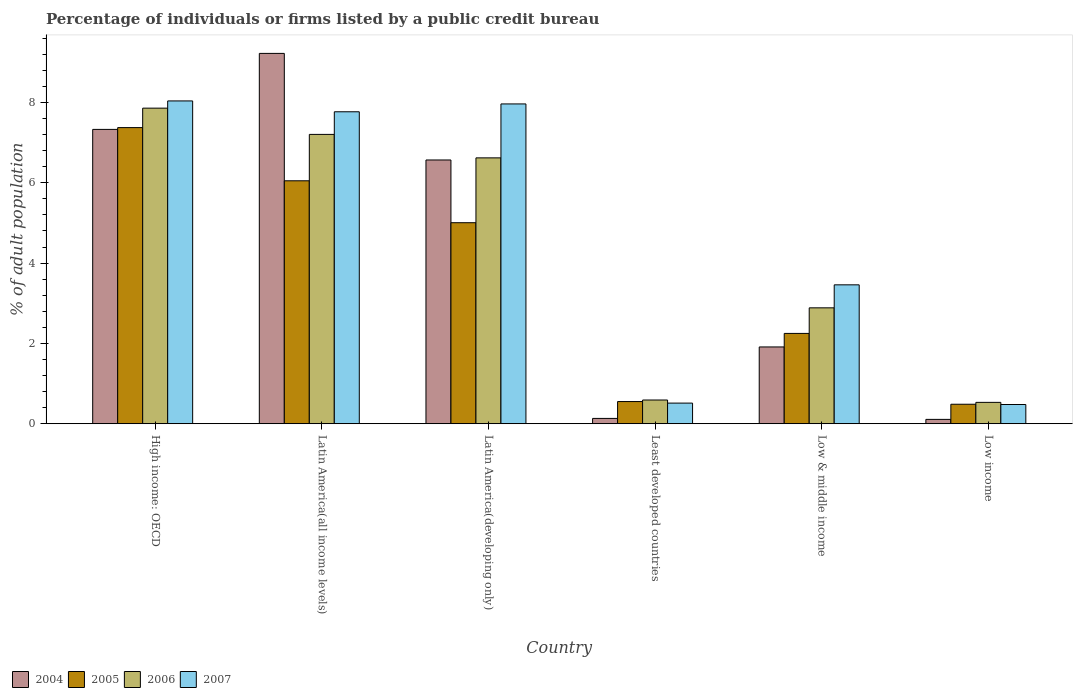How many different coloured bars are there?
Ensure brevity in your answer.  4. How many groups of bars are there?
Your answer should be very brief. 6. Are the number of bars per tick equal to the number of legend labels?
Offer a very short reply. Yes. How many bars are there on the 1st tick from the right?
Ensure brevity in your answer.  4. What is the label of the 5th group of bars from the left?
Keep it short and to the point. Low & middle income. In how many cases, is the number of bars for a given country not equal to the number of legend labels?
Ensure brevity in your answer.  0. What is the percentage of population listed by a public credit bureau in 2004 in Low & middle income?
Offer a terse response. 1.91. Across all countries, what is the maximum percentage of population listed by a public credit bureau in 2007?
Ensure brevity in your answer.  8.04. Across all countries, what is the minimum percentage of population listed by a public credit bureau in 2006?
Ensure brevity in your answer.  0.53. In which country was the percentage of population listed by a public credit bureau in 2006 maximum?
Provide a succinct answer. High income: OECD. In which country was the percentage of population listed by a public credit bureau in 2004 minimum?
Keep it short and to the point. Low income. What is the total percentage of population listed by a public credit bureau in 2007 in the graph?
Offer a terse response. 28.22. What is the difference between the percentage of population listed by a public credit bureau in 2006 in High income: OECD and that in Low income?
Your response must be concise. 7.32. What is the difference between the percentage of population listed by a public credit bureau in 2006 in Latin America(developing only) and the percentage of population listed by a public credit bureau in 2007 in Low & middle income?
Offer a terse response. 3.16. What is the average percentage of population listed by a public credit bureau in 2004 per country?
Provide a short and direct response. 4.21. What is the difference between the percentage of population listed by a public credit bureau of/in 2007 and percentage of population listed by a public credit bureau of/in 2006 in Low income?
Keep it short and to the point. -0.05. What is the ratio of the percentage of population listed by a public credit bureau in 2006 in High income: OECD to that in Latin America(developing only)?
Your answer should be compact. 1.19. What is the difference between the highest and the second highest percentage of population listed by a public credit bureau in 2005?
Ensure brevity in your answer.  -1.04. What is the difference between the highest and the lowest percentage of population listed by a public credit bureau in 2004?
Your answer should be compact. 9.11. Is the sum of the percentage of population listed by a public credit bureau in 2005 in Latin America(all income levels) and Least developed countries greater than the maximum percentage of population listed by a public credit bureau in 2007 across all countries?
Give a very brief answer. No. What does the 4th bar from the left in High income: OECD represents?
Provide a succinct answer. 2007. What does the 3rd bar from the right in High income: OECD represents?
Provide a short and direct response. 2005. Are all the bars in the graph horizontal?
Provide a succinct answer. No. Are the values on the major ticks of Y-axis written in scientific E-notation?
Offer a terse response. No. Does the graph contain any zero values?
Provide a succinct answer. No. Does the graph contain grids?
Your answer should be compact. No. Where does the legend appear in the graph?
Your answer should be compact. Bottom left. How many legend labels are there?
Provide a short and direct response. 4. How are the legend labels stacked?
Offer a very short reply. Horizontal. What is the title of the graph?
Ensure brevity in your answer.  Percentage of individuals or firms listed by a public credit bureau. What is the label or title of the X-axis?
Your answer should be compact. Country. What is the label or title of the Y-axis?
Your answer should be compact. % of adult population. What is the % of adult population of 2004 in High income: OECD?
Keep it short and to the point. 7.33. What is the % of adult population of 2005 in High income: OECD?
Offer a very short reply. 7.37. What is the % of adult population of 2006 in High income: OECD?
Provide a short and direct response. 7.86. What is the % of adult population of 2007 in High income: OECD?
Ensure brevity in your answer.  8.04. What is the % of adult population of 2004 in Latin America(all income levels)?
Your answer should be very brief. 9.22. What is the % of adult population in 2005 in Latin America(all income levels)?
Provide a short and direct response. 6.05. What is the % of adult population of 2006 in Latin America(all income levels)?
Provide a succinct answer. 7.2. What is the % of adult population in 2007 in Latin America(all income levels)?
Provide a short and direct response. 7.77. What is the % of adult population in 2004 in Latin America(developing only)?
Offer a terse response. 6.57. What is the % of adult population of 2005 in Latin America(developing only)?
Keep it short and to the point. 5. What is the % of adult population of 2006 in Latin America(developing only)?
Provide a short and direct response. 6.62. What is the % of adult population of 2007 in Latin America(developing only)?
Your response must be concise. 7.96. What is the % of adult population of 2004 in Least developed countries?
Your response must be concise. 0.13. What is the % of adult population of 2005 in Least developed countries?
Provide a succinct answer. 0.55. What is the % of adult population in 2006 in Least developed countries?
Keep it short and to the point. 0.59. What is the % of adult population in 2007 in Least developed countries?
Your answer should be very brief. 0.51. What is the % of adult population of 2004 in Low & middle income?
Ensure brevity in your answer.  1.91. What is the % of adult population of 2005 in Low & middle income?
Provide a succinct answer. 2.25. What is the % of adult population of 2006 in Low & middle income?
Offer a very short reply. 2.89. What is the % of adult population of 2007 in Low & middle income?
Keep it short and to the point. 3.46. What is the % of adult population in 2004 in Low income?
Your response must be concise. 0.11. What is the % of adult population in 2005 in Low income?
Your answer should be compact. 0.49. What is the % of adult population of 2006 in Low income?
Give a very brief answer. 0.53. What is the % of adult population of 2007 in Low income?
Keep it short and to the point. 0.48. Across all countries, what is the maximum % of adult population in 2004?
Give a very brief answer. 9.22. Across all countries, what is the maximum % of adult population of 2005?
Your answer should be compact. 7.37. Across all countries, what is the maximum % of adult population in 2006?
Give a very brief answer. 7.86. Across all countries, what is the maximum % of adult population of 2007?
Your answer should be very brief. 8.04. Across all countries, what is the minimum % of adult population in 2004?
Make the answer very short. 0.11. Across all countries, what is the minimum % of adult population of 2005?
Keep it short and to the point. 0.49. Across all countries, what is the minimum % of adult population in 2006?
Your answer should be compact. 0.53. Across all countries, what is the minimum % of adult population of 2007?
Provide a succinct answer. 0.48. What is the total % of adult population of 2004 in the graph?
Keep it short and to the point. 25.27. What is the total % of adult population of 2005 in the graph?
Offer a very short reply. 21.71. What is the total % of adult population in 2006 in the graph?
Your response must be concise. 25.69. What is the total % of adult population of 2007 in the graph?
Ensure brevity in your answer.  28.22. What is the difference between the % of adult population of 2004 in High income: OECD and that in Latin America(all income levels)?
Offer a very short reply. -1.89. What is the difference between the % of adult population of 2005 in High income: OECD and that in Latin America(all income levels)?
Provide a short and direct response. 1.32. What is the difference between the % of adult population of 2006 in High income: OECD and that in Latin America(all income levels)?
Your answer should be very brief. 0.65. What is the difference between the % of adult population in 2007 in High income: OECD and that in Latin America(all income levels)?
Offer a terse response. 0.27. What is the difference between the % of adult population of 2004 in High income: OECD and that in Latin America(developing only)?
Ensure brevity in your answer.  0.76. What is the difference between the % of adult population of 2005 in High income: OECD and that in Latin America(developing only)?
Offer a terse response. 2.37. What is the difference between the % of adult population of 2006 in High income: OECD and that in Latin America(developing only)?
Provide a short and direct response. 1.24. What is the difference between the % of adult population of 2007 in High income: OECD and that in Latin America(developing only)?
Ensure brevity in your answer.  0.07. What is the difference between the % of adult population of 2004 in High income: OECD and that in Least developed countries?
Give a very brief answer. 7.2. What is the difference between the % of adult population of 2005 in High income: OECD and that in Least developed countries?
Your answer should be compact. 6.82. What is the difference between the % of adult population in 2006 in High income: OECD and that in Least developed countries?
Make the answer very short. 7.27. What is the difference between the % of adult population in 2007 in High income: OECD and that in Least developed countries?
Offer a very short reply. 7.52. What is the difference between the % of adult population of 2004 in High income: OECD and that in Low & middle income?
Provide a short and direct response. 5.42. What is the difference between the % of adult population of 2005 in High income: OECD and that in Low & middle income?
Offer a very short reply. 5.12. What is the difference between the % of adult population of 2006 in High income: OECD and that in Low & middle income?
Your answer should be compact. 4.97. What is the difference between the % of adult population of 2007 in High income: OECD and that in Low & middle income?
Your response must be concise. 4.58. What is the difference between the % of adult population of 2004 in High income: OECD and that in Low income?
Make the answer very short. 7.22. What is the difference between the % of adult population in 2005 in High income: OECD and that in Low income?
Ensure brevity in your answer.  6.89. What is the difference between the % of adult population in 2006 in High income: OECD and that in Low income?
Provide a succinct answer. 7.32. What is the difference between the % of adult population of 2007 in High income: OECD and that in Low income?
Provide a succinct answer. 7.56. What is the difference between the % of adult population in 2004 in Latin America(all income levels) and that in Latin America(developing only)?
Your answer should be compact. 2.65. What is the difference between the % of adult population of 2005 in Latin America(all income levels) and that in Latin America(developing only)?
Your response must be concise. 1.04. What is the difference between the % of adult population of 2006 in Latin America(all income levels) and that in Latin America(developing only)?
Your answer should be very brief. 0.58. What is the difference between the % of adult population in 2007 in Latin America(all income levels) and that in Latin America(developing only)?
Give a very brief answer. -0.2. What is the difference between the % of adult population in 2004 in Latin America(all income levels) and that in Least developed countries?
Provide a short and direct response. 9.09. What is the difference between the % of adult population of 2005 in Latin America(all income levels) and that in Least developed countries?
Make the answer very short. 5.5. What is the difference between the % of adult population of 2006 in Latin America(all income levels) and that in Least developed countries?
Your answer should be compact. 6.61. What is the difference between the % of adult population in 2007 in Latin America(all income levels) and that in Least developed countries?
Your response must be concise. 7.25. What is the difference between the % of adult population of 2004 in Latin America(all income levels) and that in Low & middle income?
Make the answer very short. 7.31. What is the difference between the % of adult population in 2005 in Latin America(all income levels) and that in Low & middle income?
Your answer should be very brief. 3.8. What is the difference between the % of adult population in 2006 in Latin America(all income levels) and that in Low & middle income?
Ensure brevity in your answer.  4.32. What is the difference between the % of adult population in 2007 in Latin America(all income levels) and that in Low & middle income?
Give a very brief answer. 4.31. What is the difference between the % of adult population of 2004 in Latin America(all income levels) and that in Low income?
Offer a very short reply. 9.11. What is the difference between the % of adult population in 2005 in Latin America(all income levels) and that in Low income?
Provide a succinct answer. 5.56. What is the difference between the % of adult population of 2006 in Latin America(all income levels) and that in Low income?
Provide a short and direct response. 6.67. What is the difference between the % of adult population in 2007 in Latin America(all income levels) and that in Low income?
Keep it short and to the point. 7.29. What is the difference between the % of adult population of 2004 in Latin America(developing only) and that in Least developed countries?
Provide a short and direct response. 6.43. What is the difference between the % of adult population in 2005 in Latin America(developing only) and that in Least developed countries?
Offer a terse response. 4.45. What is the difference between the % of adult population in 2006 in Latin America(developing only) and that in Least developed countries?
Give a very brief answer. 6.03. What is the difference between the % of adult population in 2007 in Latin America(developing only) and that in Least developed countries?
Offer a very short reply. 7.45. What is the difference between the % of adult population of 2004 in Latin America(developing only) and that in Low & middle income?
Offer a very short reply. 4.65. What is the difference between the % of adult population in 2005 in Latin America(developing only) and that in Low & middle income?
Provide a short and direct response. 2.76. What is the difference between the % of adult population in 2006 in Latin America(developing only) and that in Low & middle income?
Offer a very short reply. 3.73. What is the difference between the % of adult population of 2007 in Latin America(developing only) and that in Low & middle income?
Your response must be concise. 4.5. What is the difference between the % of adult population of 2004 in Latin America(developing only) and that in Low income?
Keep it short and to the point. 6.46. What is the difference between the % of adult population of 2005 in Latin America(developing only) and that in Low income?
Keep it short and to the point. 4.52. What is the difference between the % of adult population of 2006 in Latin America(developing only) and that in Low income?
Keep it short and to the point. 6.09. What is the difference between the % of adult population of 2007 in Latin America(developing only) and that in Low income?
Offer a very short reply. 7.48. What is the difference between the % of adult population in 2004 in Least developed countries and that in Low & middle income?
Offer a terse response. -1.78. What is the difference between the % of adult population of 2005 in Least developed countries and that in Low & middle income?
Make the answer very short. -1.7. What is the difference between the % of adult population of 2006 in Least developed countries and that in Low & middle income?
Your answer should be very brief. -2.29. What is the difference between the % of adult population of 2007 in Least developed countries and that in Low & middle income?
Your answer should be very brief. -2.94. What is the difference between the % of adult population in 2004 in Least developed countries and that in Low income?
Your response must be concise. 0.02. What is the difference between the % of adult population of 2005 in Least developed countries and that in Low income?
Ensure brevity in your answer.  0.07. What is the difference between the % of adult population in 2006 in Least developed countries and that in Low income?
Provide a succinct answer. 0.06. What is the difference between the % of adult population in 2007 in Least developed countries and that in Low income?
Ensure brevity in your answer.  0.04. What is the difference between the % of adult population of 2004 in Low & middle income and that in Low income?
Your answer should be compact. 1.8. What is the difference between the % of adult population of 2005 in Low & middle income and that in Low income?
Give a very brief answer. 1.76. What is the difference between the % of adult population of 2006 in Low & middle income and that in Low income?
Make the answer very short. 2.35. What is the difference between the % of adult population in 2007 in Low & middle income and that in Low income?
Give a very brief answer. 2.98. What is the difference between the % of adult population of 2004 in High income: OECD and the % of adult population of 2005 in Latin America(all income levels)?
Give a very brief answer. 1.28. What is the difference between the % of adult population in 2004 in High income: OECD and the % of adult population in 2006 in Latin America(all income levels)?
Provide a succinct answer. 0.12. What is the difference between the % of adult population in 2004 in High income: OECD and the % of adult population in 2007 in Latin America(all income levels)?
Make the answer very short. -0.44. What is the difference between the % of adult population of 2005 in High income: OECD and the % of adult population of 2006 in Latin America(all income levels)?
Provide a succinct answer. 0.17. What is the difference between the % of adult population of 2005 in High income: OECD and the % of adult population of 2007 in Latin America(all income levels)?
Offer a terse response. -0.39. What is the difference between the % of adult population in 2006 in High income: OECD and the % of adult population in 2007 in Latin America(all income levels)?
Your response must be concise. 0.09. What is the difference between the % of adult population of 2004 in High income: OECD and the % of adult population of 2005 in Latin America(developing only)?
Offer a terse response. 2.32. What is the difference between the % of adult population of 2004 in High income: OECD and the % of adult population of 2006 in Latin America(developing only)?
Make the answer very short. 0.71. What is the difference between the % of adult population in 2004 in High income: OECD and the % of adult population in 2007 in Latin America(developing only)?
Give a very brief answer. -0.63. What is the difference between the % of adult population of 2005 in High income: OECD and the % of adult population of 2006 in Latin America(developing only)?
Your response must be concise. 0.75. What is the difference between the % of adult population of 2005 in High income: OECD and the % of adult population of 2007 in Latin America(developing only)?
Make the answer very short. -0.59. What is the difference between the % of adult population in 2006 in High income: OECD and the % of adult population in 2007 in Latin America(developing only)?
Offer a terse response. -0.11. What is the difference between the % of adult population of 2004 in High income: OECD and the % of adult population of 2005 in Least developed countries?
Keep it short and to the point. 6.78. What is the difference between the % of adult population of 2004 in High income: OECD and the % of adult population of 2006 in Least developed countries?
Offer a very short reply. 6.74. What is the difference between the % of adult population in 2004 in High income: OECD and the % of adult population in 2007 in Least developed countries?
Your response must be concise. 6.81. What is the difference between the % of adult population in 2005 in High income: OECD and the % of adult population in 2006 in Least developed countries?
Offer a very short reply. 6.78. What is the difference between the % of adult population of 2005 in High income: OECD and the % of adult population of 2007 in Least developed countries?
Keep it short and to the point. 6.86. What is the difference between the % of adult population in 2006 in High income: OECD and the % of adult population in 2007 in Least developed countries?
Provide a short and direct response. 7.34. What is the difference between the % of adult population of 2004 in High income: OECD and the % of adult population of 2005 in Low & middle income?
Your response must be concise. 5.08. What is the difference between the % of adult population of 2004 in High income: OECD and the % of adult population of 2006 in Low & middle income?
Give a very brief answer. 4.44. What is the difference between the % of adult population in 2004 in High income: OECD and the % of adult population in 2007 in Low & middle income?
Your response must be concise. 3.87. What is the difference between the % of adult population in 2005 in High income: OECD and the % of adult population in 2006 in Low & middle income?
Give a very brief answer. 4.49. What is the difference between the % of adult population of 2005 in High income: OECD and the % of adult population of 2007 in Low & middle income?
Keep it short and to the point. 3.91. What is the difference between the % of adult population in 2006 in High income: OECD and the % of adult population in 2007 in Low & middle income?
Offer a very short reply. 4.4. What is the difference between the % of adult population in 2004 in High income: OECD and the % of adult population in 2005 in Low income?
Your answer should be compact. 6.84. What is the difference between the % of adult population of 2004 in High income: OECD and the % of adult population of 2006 in Low income?
Provide a short and direct response. 6.8. What is the difference between the % of adult population in 2004 in High income: OECD and the % of adult population in 2007 in Low income?
Your answer should be compact. 6.85. What is the difference between the % of adult population of 2005 in High income: OECD and the % of adult population of 2006 in Low income?
Your response must be concise. 6.84. What is the difference between the % of adult population of 2005 in High income: OECD and the % of adult population of 2007 in Low income?
Make the answer very short. 6.89. What is the difference between the % of adult population in 2006 in High income: OECD and the % of adult population in 2007 in Low income?
Ensure brevity in your answer.  7.38. What is the difference between the % of adult population of 2004 in Latin America(all income levels) and the % of adult population of 2005 in Latin America(developing only)?
Your answer should be very brief. 4.22. What is the difference between the % of adult population in 2004 in Latin America(all income levels) and the % of adult population in 2006 in Latin America(developing only)?
Offer a very short reply. 2.6. What is the difference between the % of adult population of 2004 in Latin America(all income levels) and the % of adult population of 2007 in Latin America(developing only)?
Offer a terse response. 1.26. What is the difference between the % of adult population in 2005 in Latin America(all income levels) and the % of adult population in 2006 in Latin America(developing only)?
Give a very brief answer. -0.57. What is the difference between the % of adult population in 2005 in Latin America(all income levels) and the % of adult population in 2007 in Latin America(developing only)?
Keep it short and to the point. -1.91. What is the difference between the % of adult population in 2006 in Latin America(all income levels) and the % of adult population in 2007 in Latin America(developing only)?
Provide a short and direct response. -0.76. What is the difference between the % of adult population of 2004 in Latin America(all income levels) and the % of adult population of 2005 in Least developed countries?
Ensure brevity in your answer.  8.67. What is the difference between the % of adult population in 2004 in Latin America(all income levels) and the % of adult population in 2006 in Least developed countries?
Keep it short and to the point. 8.63. What is the difference between the % of adult population of 2004 in Latin America(all income levels) and the % of adult population of 2007 in Least developed countries?
Provide a short and direct response. 8.71. What is the difference between the % of adult population of 2005 in Latin America(all income levels) and the % of adult population of 2006 in Least developed countries?
Provide a short and direct response. 5.46. What is the difference between the % of adult population of 2005 in Latin America(all income levels) and the % of adult population of 2007 in Least developed countries?
Ensure brevity in your answer.  5.53. What is the difference between the % of adult population of 2006 in Latin America(all income levels) and the % of adult population of 2007 in Least developed countries?
Provide a short and direct response. 6.69. What is the difference between the % of adult population in 2004 in Latin America(all income levels) and the % of adult population in 2005 in Low & middle income?
Provide a succinct answer. 6.97. What is the difference between the % of adult population in 2004 in Latin America(all income levels) and the % of adult population in 2006 in Low & middle income?
Offer a terse response. 6.33. What is the difference between the % of adult population in 2004 in Latin America(all income levels) and the % of adult population in 2007 in Low & middle income?
Ensure brevity in your answer.  5.76. What is the difference between the % of adult population of 2005 in Latin America(all income levels) and the % of adult population of 2006 in Low & middle income?
Give a very brief answer. 3.16. What is the difference between the % of adult population of 2005 in Latin America(all income levels) and the % of adult population of 2007 in Low & middle income?
Keep it short and to the point. 2.59. What is the difference between the % of adult population of 2006 in Latin America(all income levels) and the % of adult population of 2007 in Low & middle income?
Your answer should be compact. 3.75. What is the difference between the % of adult population of 2004 in Latin America(all income levels) and the % of adult population of 2005 in Low income?
Ensure brevity in your answer.  8.73. What is the difference between the % of adult population in 2004 in Latin America(all income levels) and the % of adult population in 2006 in Low income?
Offer a terse response. 8.69. What is the difference between the % of adult population of 2004 in Latin America(all income levels) and the % of adult population of 2007 in Low income?
Give a very brief answer. 8.74. What is the difference between the % of adult population of 2005 in Latin America(all income levels) and the % of adult population of 2006 in Low income?
Keep it short and to the point. 5.52. What is the difference between the % of adult population of 2005 in Latin America(all income levels) and the % of adult population of 2007 in Low income?
Provide a succinct answer. 5.57. What is the difference between the % of adult population in 2006 in Latin America(all income levels) and the % of adult population in 2007 in Low income?
Make the answer very short. 6.72. What is the difference between the % of adult population in 2004 in Latin America(developing only) and the % of adult population in 2005 in Least developed countries?
Your answer should be very brief. 6.01. What is the difference between the % of adult population in 2004 in Latin America(developing only) and the % of adult population in 2006 in Least developed countries?
Offer a very short reply. 5.98. What is the difference between the % of adult population in 2004 in Latin America(developing only) and the % of adult population in 2007 in Least developed countries?
Make the answer very short. 6.05. What is the difference between the % of adult population of 2005 in Latin America(developing only) and the % of adult population of 2006 in Least developed countries?
Give a very brief answer. 4.41. What is the difference between the % of adult population in 2005 in Latin America(developing only) and the % of adult population in 2007 in Least developed countries?
Your response must be concise. 4.49. What is the difference between the % of adult population of 2006 in Latin America(developing only) and the % of adult population of 2007 in Least developed countries?
Offer a terse response. 6.11. What is the difference between the % of adult population of 2004 in Latin America(developing only) and the % of adult population of 2005 in Low & middle income?
Give a very brief answer. 4.32. What is the difference between the % of adult population in 2004 in Latin America(developing only) and the % of adult population in 2006 in Low & middle income?
Provide a succinct answer. 3.68. What is the difference between the % of adult population of 2004 in Latin America(developing only) and the % of adult population of 2007 in Low & middle income?
Make the answer very short. 3.11. What is the difference between the % of adult population in 2005 in Latin America(developing only) and the % of adult population in 2006 in Low & middle income?
Ensure brevity in your answer.  2.12. What is the difference between the % of adult population in 2005 in Latin America(developing only) and the % of adult population in 2007 in Low & middle income?
Your answer should be very brief. 1.55. What is the difference between the % of adult population in 2006 in Latin America(developing only) and the % of adult population in 2007 in Low & middle income?
Offer a very short reply. 3.16. What is the difference between the % of adult population of 2004 in Latin America(developing only) and the % of adult population of 2005 in Low income?
Your response must be concise. 6.08. What is the difference between the % of adult population in 2004 in Latin America(developing only) and the % of adult population in 2006 in Low income?
Make the answer very short. 6.03. What is the difference between the % of adult population in 2004 in Latin America(developing only) and the % of adult population in 2007 in Low income?
Provide a short and direct response. 6.09. What is the difference between the % of adult population of 2005 in Latin America(developing only) and the % of adult population of 2006 in Low income?
Keep it short and to the point. 4.47. What is the difference between the % of adult population of 2005 in Latin America(developing only) and the % of adult population of 2007 in Low income?
Give a very brief answer. 4.53. What is the difference between the % of adult population of 2006 in Latin America(developing only) and the % of adult population of 2007 in Low income?
Your answer should be very brief. 6.14. What is the difference between the % of adult population in 2004 in Least developed countries and the % of adult population in 2005 in Low & middle income?
Your answer should be compact. -2.12. What is the difference between the % of adult population of 2004 in Least developed countries and the % of adult population of 2006 in Low & middle income?
Your answer should be very brief. -2.75. What is the difference between the % of adult population in 2004 in Least developed countries and the % of adult population in 2007 in Low & middle income?
Your answer should be compact. -3.33. What is the difference between the % of adult population in 2005 in Least developed countries and the % of adult population in 2006 in Low & middle income?
Your answer should be very brief. -2.33. What is the difference between the % of adult population in 2005 in Least developed countries and the % of adult population in 2007 in Low & middle income?
Provide a short and direct response. -2.91. What is the difference between the % of adult population in 2006 in Least developed countries and the % of adult population in 2007 in Low & middle income?
Provide a short and direct response. -2.87. What is the difference between the % of adult population of 2004 in Least developed countries and the % of adult population of 2005 in Low income?
Provide a succinct answer. -0.35. What is the difference between the % of adult population of 2004 in Least developed countries and the % of adult population of 2006 in Low income?
Ensure brevity in your answer.  -0.4. What is the difference between the % of adult population of 2004 in Least developed countries and the % of adult population of 2007 in Low income?
Your answer should be very brief. -0.35. What is the difference between the % of adult population in 2005 in Least developed countries and the % of adult population in 2006 in Low income?
Your response must be concise. 0.02. What is the difference between the % of adult population in 2005 in Least developed countries and the % of adult population in 2007 in Low income?
Make the answer very short. 0.07. What is the difference between the % of adult population in 2006 in Least developed countries and the % of adult population in 2007 in Low income?
Provide a short and direct response. 0.11. What is the difference between the % of adult population of 2004 in Low & middle income and the % of adult population of 2005 in Low income?
Provide a short and direct response. 1.43. What is the difference between the % of adult population of 2004 in Low & middle income and the % of adult population of 2006 in Low income?
Offer a very short reply. 1.38. What is the difference between the % of adult population of 2004 in Low & middle income and the % of adult population of 2007 in Low income?
Make the answer very short. 1.43. What is the difference between the % of adult population in 2005 in Low & middle income and the % of adult population in 2006 in Low income?
Keep it short and to the point. 1.72. What is the difference between the % of adult population of 2005 in Low & middle income and the % of adult population of 2007 in Low income?
Offer a terse response. 1.77. What is the difference between the % of adult population of 2006 in Low & middle income and the % of adult population of 2007 in Low income?
Offer a very short reply. 2.41. What is the average % of adult population in 2004 per country?
Make the answer very short. 4.21. What is the average % of adult population of 2005 per country?
Provide a short and direct response. 3.62. What is the average % of adult population of 2006 per country?
Offer a very short reply. 4.28. What is the average % of adult population of 2007 per country?
Offer a very short reply. 4.7. What is the difference between the % of adult population in 2004 and % of adult population in 2005 in High income: OECD?
Provide a succinct answer. -0.04. What is the difference between the % of adult population of 2004 and % of adult population of 2006 in High income: OECD?
Your answer should be very brief. -0.53. What is the difference between the % of adult population in 2004 and % of adult population in 2007 in High income: OECD?
Ensure brevity in your answer.  -0.71. What is the difference between the % of adult population in 2005 and % of adult population in 2006 in High income: OECD?
Your answer should be very brief. -0.48. What is the difference between the % of adult population of 2005 and % of adult population of 2007 in High income: OECD?
Ensure brevity in your answer.  -0.66. What is the difference between the % of adult population of 2006 and % of adult population of 2007 in High income: OECD?
Offer a very short reply. -0.18. What is the difference between the % of adult population of 2004 and % of adult population of 2005 in Latin America(all income levels)?
Provide a short and direct response. 3.17. What is the difference between the % of adult population in 2004 and % of adult population in 2006 in Latin America(all income levels)?
Give a very brief answer. 2.02. What is the difference between the % of adult population in 2004 and % of adult population in 2007 in Latin America(all income levels)?
Your answer should be compact. 1.45. What is the difference between the % of adult population in 2005 and % of adult population in 2006 in Latin America(all income levels)?
Offer a very short reply. -1.16. What is the difference between the % of adult population in 2005 and % of adult population in 2007 in Latin America(all income levels)?
Ensure brevity in your answer.  -1.72. What is the difference between the % of adult population of 2006 and % of adult population of 2007 in Latin America(all income levels)?
Keep it short and to the point. -0.56. What is the difference between the % of adult population of 2004 and % of adult population of 2005 in Latin America(developing only)?
Make the answer very short. 1.56. What is the difference between the % of adult population of 2004 and % of adult population of 2006 in Latin America(developing only)?
Offer a terse response. -0.05. What is the difference between the % of adult population of 2004 and % of adult population of 2007 in Latin America(developing only)?
Ensure brevity in your answer.  -1.4. What is the difference between the % of adult population of 2005 and % of adult population of 2006 in Latin America(developing only)?
Offer a very short reply. -1.61. What is the difference between the % of adult population of 2005 and % of adult population of 2007 in Latin America(developing only)?
Make the answer very short. -2.96. What is the difference between the % of adult population of 2006 and % of adult population of 2007 in Latin America(developing only)?
Offer a very short reply. -1.34. What is the difference between the % of adult population of 2004 and % of adult population of 2005 in Least developed countries?
Make the answer very short. -0.42. What is the difference between the % of adult population of 2004 and % of adult population of 2006 in Least developed countries?
Your answer should be compact. -0.46. What is the difference between the % of adult population of 2004 and % of adult population of 2007 in Least developed countries?
Offer a very short reply. -0.38. What is the difference between the % of adult population of 2005 and % of adult population of 2006 in Least developed countries?
Make the answer very short. -0.04. What is the difference between the % of adult population of 2005 and % of adult population of 2007 in Least developed countries?
Offer a very short reply. 0.04. What is the difference between the % of adult population in 2006 and % of adult population in 2007 in Least developed countries?
Provide a short and direct response. 0.08. What is the difference between the % of adult population of 2004 and % of adult population of 2005 in Low & middle income?
Provide a succinct answer. -0.34. What is the difference between the % of adult population of 2004 and % of adult population of 2006 in Low & middle income?
Your response must be concise. -0.97. What is the difference between the % of adult population in 2004 and % of adult population in 2007 in Low & middle income?
Give a very brief answer. -1.55. What is the difference between the % of adult population in 2005 and % of adult population in 2006 in Low & middle income?
Offer a very short reply. -0.64. What is the difference between the % of adult population in 2005 and % of adult population in 2007 in Low & middle income?
Keep it short and to the point. -1.21. What is the difference between the % of adult population in 2006 and % of adult population in 2007 in Low & middle income?
Ensure brevity in your answer.  -0.57. What is the difference between the % of adult population of 2004 and % of adult population of 2005 in Low income?
Provide a short and direct response. -0.38. What is the difference between the % of adult population of 2004 and % of adult population of 2006 in Low income?
Your answer should be very brief. -0.42. What is the difference between the % of adult population of 2004 and % of adult population of 2007 in Low income?
Make the answer very short. -0.37. What is the difference between the % of adult population in 2005 and % of adult population in 2006 in Low income?
Your answer should be very brief. -0.05. What is the difference between the % of adult population of 2005 and % of adult population of 2007 in Low income?
Give a very brief answer. 0.01. What is the difference between the % of adult population of 2006 and % of adult population of 2007 in Low income?
Offer a terse response. 0.05. What is the ratio of the % of adult population in 2004 in High income: OECD to that in Latin America(all income levels)?
Provide a succinct answer. 0.79. What is the ratio of the % of adult population in 2005 in High income: OECD to that in Latin America(all income levels)?
Offer a very short reply. 1.22. What is the ratio of the % of adult population in 2006 in High income: OECD to that in Latin America(all income levels)?
Provide a short and direct response. 1.09. What is the ratio of the % of adult population of 2007 in High income: OECD to that in Latin America(all income levels)?
Offer a terse response. 1.03. What is the ratio of the % of adult population of 2004 in High income: OECD to that in Latin America(developing only)?
Your answer should be very brief. 1.12. What is the ratio of the % of adult population in 2005 in High income: OECD to that in Latin America(developing only)?
Ensure brevity in your answer.  1.47. What is the ratio of the % of adult population in 2006 in High income: OECD to that in Latin America(developing only)?
Make the answer very short. 1.19. What is the ratio of the % of adult population in 2007 in High income: OECD to that in Latin America(developing only)?
Give a very brief answer. 1.01. What is the ratio of the % of adult population in 2004 in High income: OECD to that in Least developed countries?
Provide a succinct answer. 55.33. What is the ratio of the % of adult population in 2005 in High income: OECD to that in Least developed countries?
Give a very brief answer. 13.35. What is the ratio of the % of adult population in 2006 in High income: OECD to that in Least developed countries?
Give a very brief answer. 13.3. What is the ratio of the % of adult population in 2007 in High income: OECD to that in Least developed countries?
Offer a terse response. 15.64. What is the ratio of the % of adult population of 2004 in High income: OECD to that in Low & middle income?
Offer a very short reply. 3.83. What is the ratio of the % of adult population in 2005 in High income: OECD to that in Low & middle income?
Offer a very short reply. 3.28. What is the ratio of the % of adult population of 2006 in High income: OECD to that in Low & middle income?
Give a very brief answer. 2.72. What is the ratio of the % of adult population of 2007 in High income: OECD to that in Low & middle income?
Your answer should be very brief. 2.32. What is the ratio of the % of adult population in 2004 in High income: OECD to that in Low income?
Keep it short and to the point. 67.64. What is the ratio of the % of adult population of 2005 in High income: OECD to that in Low income?
Make the answer very short. 15.2. What is the ratio of the % of adult population of 2006 in High income: OECD to that in Low income?
Make the answer very short. 14.76. What is the ratio of the % of adult population of 2007 in High income: OECD to that in Low income?
Your response must be concise. 16.79. What is the ratio of the % of adult population in 2004 in Latin America(all income levels) to that in Latin America(developing only)?
Give a very brief answer. 1.4. What is the ratio of the % of adult population of 2005 in Latin America(all income levels) to that in Latin America(developing only)?
Keep it short and to the point. 1.21. What is the ratio of the % of adult population in 2006 in Latin America(all income levels) to that in Latin America(developing only)?
Give a very brief answer. 1.09. What is the ratio of the % of adult population in 2007 in Latin America(all income levels) to that in Latin America(developing only)?
Offer a very short reply. 0.98. What is the ratio of the % of adult population of 2004 in Latin America(all income levels) to that in Least developed countries?
Ensure brevity in your answer.  69.62. What is the ratio of the % of adult population in 2005 in Latin America(all income levels) to that in Least developed countries?
Provide a succinct answer. 10.95. What is the ratio of the % of adult population in 2006 in Latin America(all income levels) to that in Least developed countries?
Provide a succinct answer. 12.19. What is the ratio of the % of adult population in 2007 in Latin America(all income levels) to that in Least developed countries?
Your response must be concise. 15.11. What is the ratio of the % of adult population in 2004 in Latin America(all income levels) to that in Low & middle income?
Your answer should be very brief. 4.82. What is the ratio of the % of adult population in 2005 in Latin America(all income levels) to that in Low & middle income?
Provide a short and direct response. 2.69. What is the ratio of the % of adult population in 2006 in Latin America(all income levels) to that in Low & middle income?
Provide a succinct answer. 2.5. What is the ratio of the % of adult population of 2007 in Latin America(all income levels) to that in Low & middle income?
Give a very brief answer. 2.25. What is the ratio of the % of adult population of 2004 in Latin America(all income levels) to that in Low income?
Your response must be concise. 85.11. What is the ratio of the % of adult population of 2005 in Latin America(all income levels) to that in Low income?
Ensure brevity in your answer.  12.47. What is the ratio of the % of adult population in 2006 in Latin America(all income levels) to that in Low income?
Offer a terse response. 13.54. What is the ratio of the % of adult population of 2007 in Latin America(all income levels) to that in Low income?
Keep it short and to the point. 16.23. What is the ratio of the % of adult population of 2004 in Latin America(developing only) to that in Least developed countries?
Give a very brief answer. 49.59. What is the ratio of the % of adult population of 2005 in Latin America(developing only) to that in Least developed countries?
Ensure brevity in your answer.  9.06. What is the ratio of the % of adult population in 2006 in Latin America(developing only) to that in Least developed countries?
Make the answer very short. 11.21. What is the ratio of the % of adult population of 2007 in Latin America(developing only) to that in Least developed countries?
Provide a succinct answer. 15.49. What is the ratio of the % of adult population in 2004 in Latin America(developing only) to that in Low & middle income?
Your answer should be very brief. 3.43. What is the ratio of the % of adult population in 2005 in Latin America(developing only) to that in Low & middle income?
Make the answer very short. 2.23. What is the ratio of the % of adult population of 2006 in Latin America(developing only) to that in Low & middle income?
Your answer should be very brief. 2.29. What is the ratio of the % of adult population of 2007 in Latin America(developing only) to that in Low & middle income?
Ensure brevity in your answer.  2.3. What is the ratio of the % of adult population of 2004 in Latin America(developing only) to that in Low income?
Offer a terse response. 60.62. What is the ratio of the % of adult population in 2005 in Latin America(developing only) to that in Low income?
Your response must be concise. 10.32. What is the ratio of the % of adult population of 2006 in Latin America(developing only) to that in Low income?
Offer a terse response. 12.44. What is the ratio of the % of adult population in 2007 in Latin America(developing only) to that in Low income?
Provide a short and direct response. 16.64. What is the ratio of the % of adult population in 2004 in Least developed countries to that in Low & middle income?
Keep it short and to the point. 0.07. What is the ratio of the % of adult population of 2005 in Least developed countries to that in Low & middle income?
Your answer should be very brief. 0.25. What is the ratio of the % of adult population in 2006 in Least developed countries to that in Low & middle income?
Your answer should be compact. 0.2. What is the ratio of the % of adult population of 2007 in Least developed countries to that in Low & middle income?
Your answer should be very brief. 0.15. What is the ratio of the % of adult population of 2004 in Least developed countries to that in Low income?
Keep it short and to the point. 1.22. What is the ratio of the % of adult population in 2005 in Least developed countries to that in Low income?
Make the answer very short. 1.14. What is the ratio of the % of adult population of 2006 in Least developed countries to that in Low income?
Your answer should be very brief. 1.11. What is the ratio of the % of adult population in 2007 in Least developed countries to that in Low income?
Your answer should be very brief. 1.07. What is the ratio of the % of adult population of 2004 in Low & middle income to that in Low income?
Your response must be concise. 17.65. What is the ratio of the % of adult population of 2005 in Low & middle income to that in Low income?
Provide a succinct answer. 4.63. What is the ratio of the % of adult population in 2006 in Low & middle income to that in Low income?
Give a very brief answer. 5.42. What is the ratio of the % of adult population in 2007 in Low & middle income to that in Low income?
Offer a terse response. 7.23. What is the difference between the highest and the second highest % of adult population in 2004?
Keep it short and to the point. 1.89. What is the difference between the highest and the second highest % of adult population in 2005?
Offer a very short reply. 1.32. What is the difference between the highest and the second highest % of adult population of 2006?
Your response must be concise. 0.65. What is the difference between the highest and the second highest % of adult population in 2007?
Make the answer very short. 0.07. What is the difference between the highest and the lowest % of adult population in 2004?
Offer a very short reply. 9.11. What is the difference between the highest and the lowest % of adult population in 2005?
Ensure brevity in your answer.  6.89. What is the difference between the highest and the lowest % of adult population in 2006?
Your response must be concise. 7.32. What is the difference between the highest and the lowest % of adult population of 2007?
Ensure brevity in your answer.  7.56. 